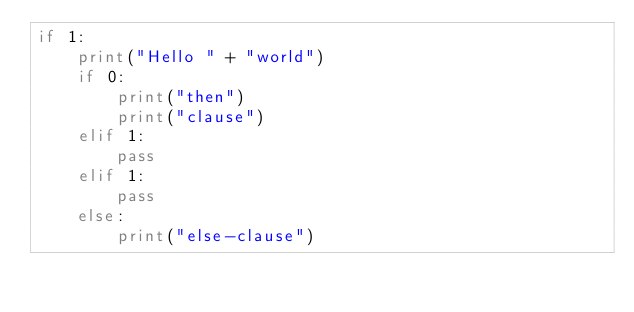Convert code to text. <code><loc_0><loc_0><loc_500><loc_500><_Python_>if 1:
    print("Hello " + "world")
    if 0:
        print("then")
        print("clause")
    elif 1:
        pass
    elif 1:
        pass
    else:
        print("else-clause")
</code> 